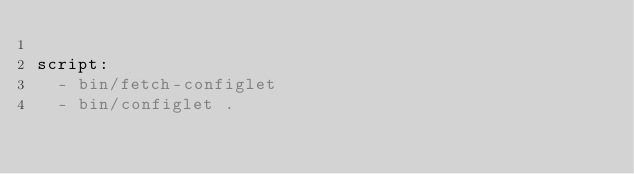<code> <loc_0><loc_0><loc_500><loc_500><_YAML_>
script:
  - bin/fetch-configlet
  - bin/configlet .
</code> 